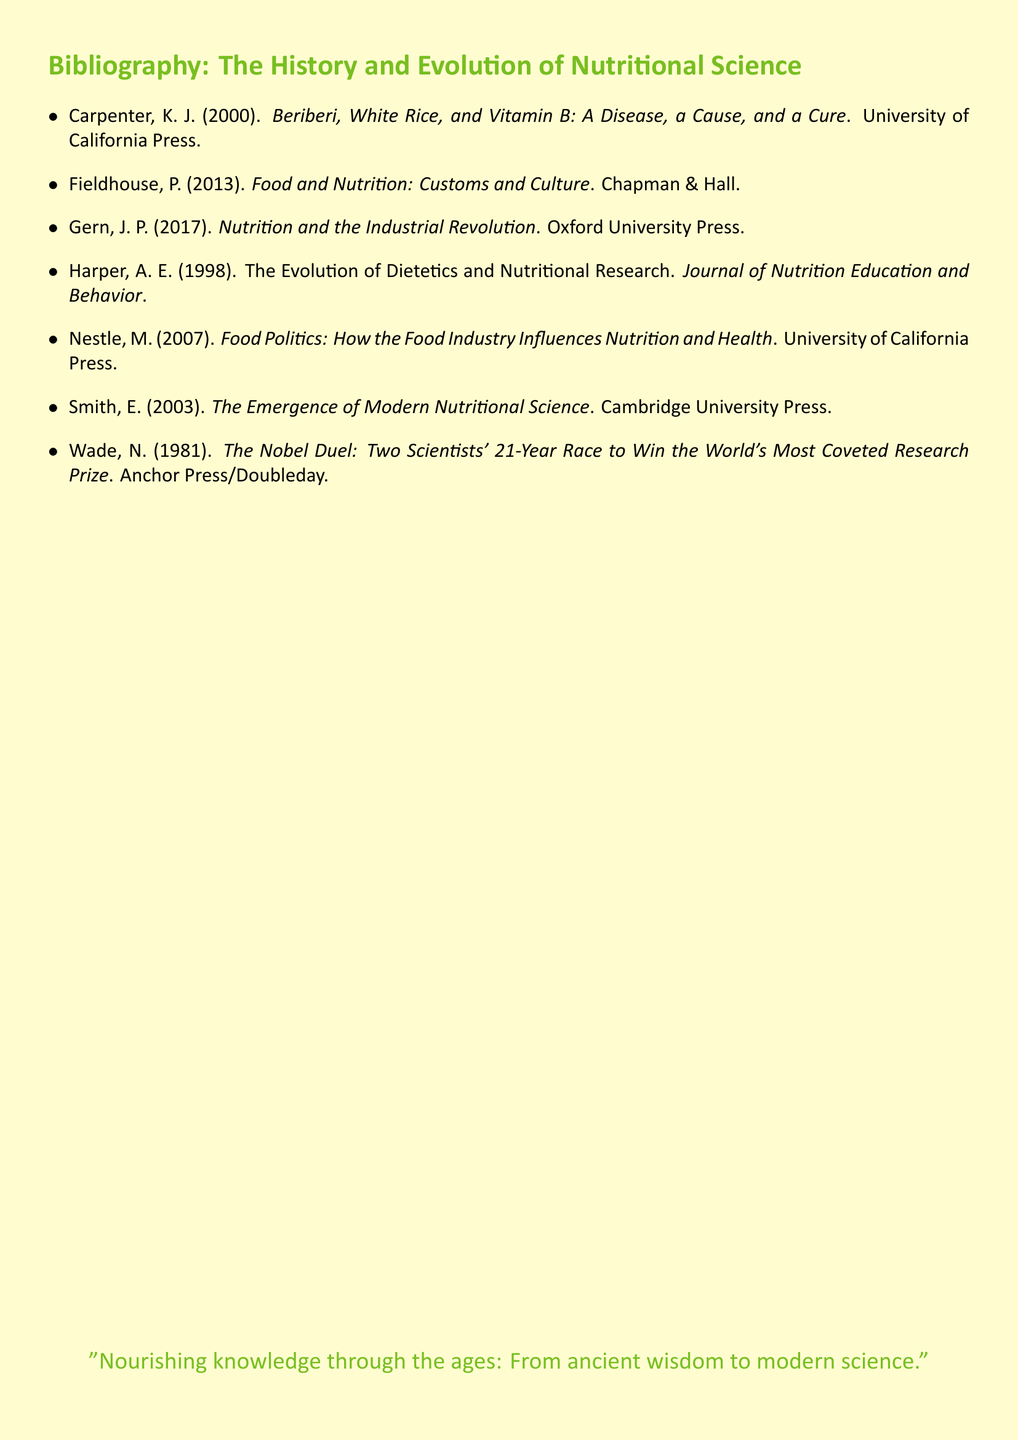What is the title of the first listed book? The title of the first book is precisely stated in the document.
Answer: Beriberi, White Rice, and Vitamin B: A Disease, a Cause, and a Cure Who authored the book "Food Politics"? The author is explicitly mentioned in the bibliography for this book.
Answer: Marion Nestle In what year was "The Emergence of Modern Nutritional Science" published? The year of publication is stated alongside the title in the document.
Answer: 2003 How many authors are cited in this bibliography? The total number of authors can be counted from the list provided.
Answer: 7 What publisher released "Nutrition and the Industrial Revolution"? The publisher associated with this book is identified in the citation.
Answer: Oxford University Press What is the main theme of the quote at the end of the document? The quote summarizes the overall objective or message conveyed by the bibliography.
Answer: Knowledge evolution What type of document is this? The format and structure of the information indicate a specific type.
Answer: Bibliography Who wrote "The Evolution of Dietetics and Nutritional Research"? The author's name is presented explicitly next to the title in the list.
Answer: A. E. Harper What is the color of the page background? The document specifies a color setting for the background.
Answer: Soft cream 